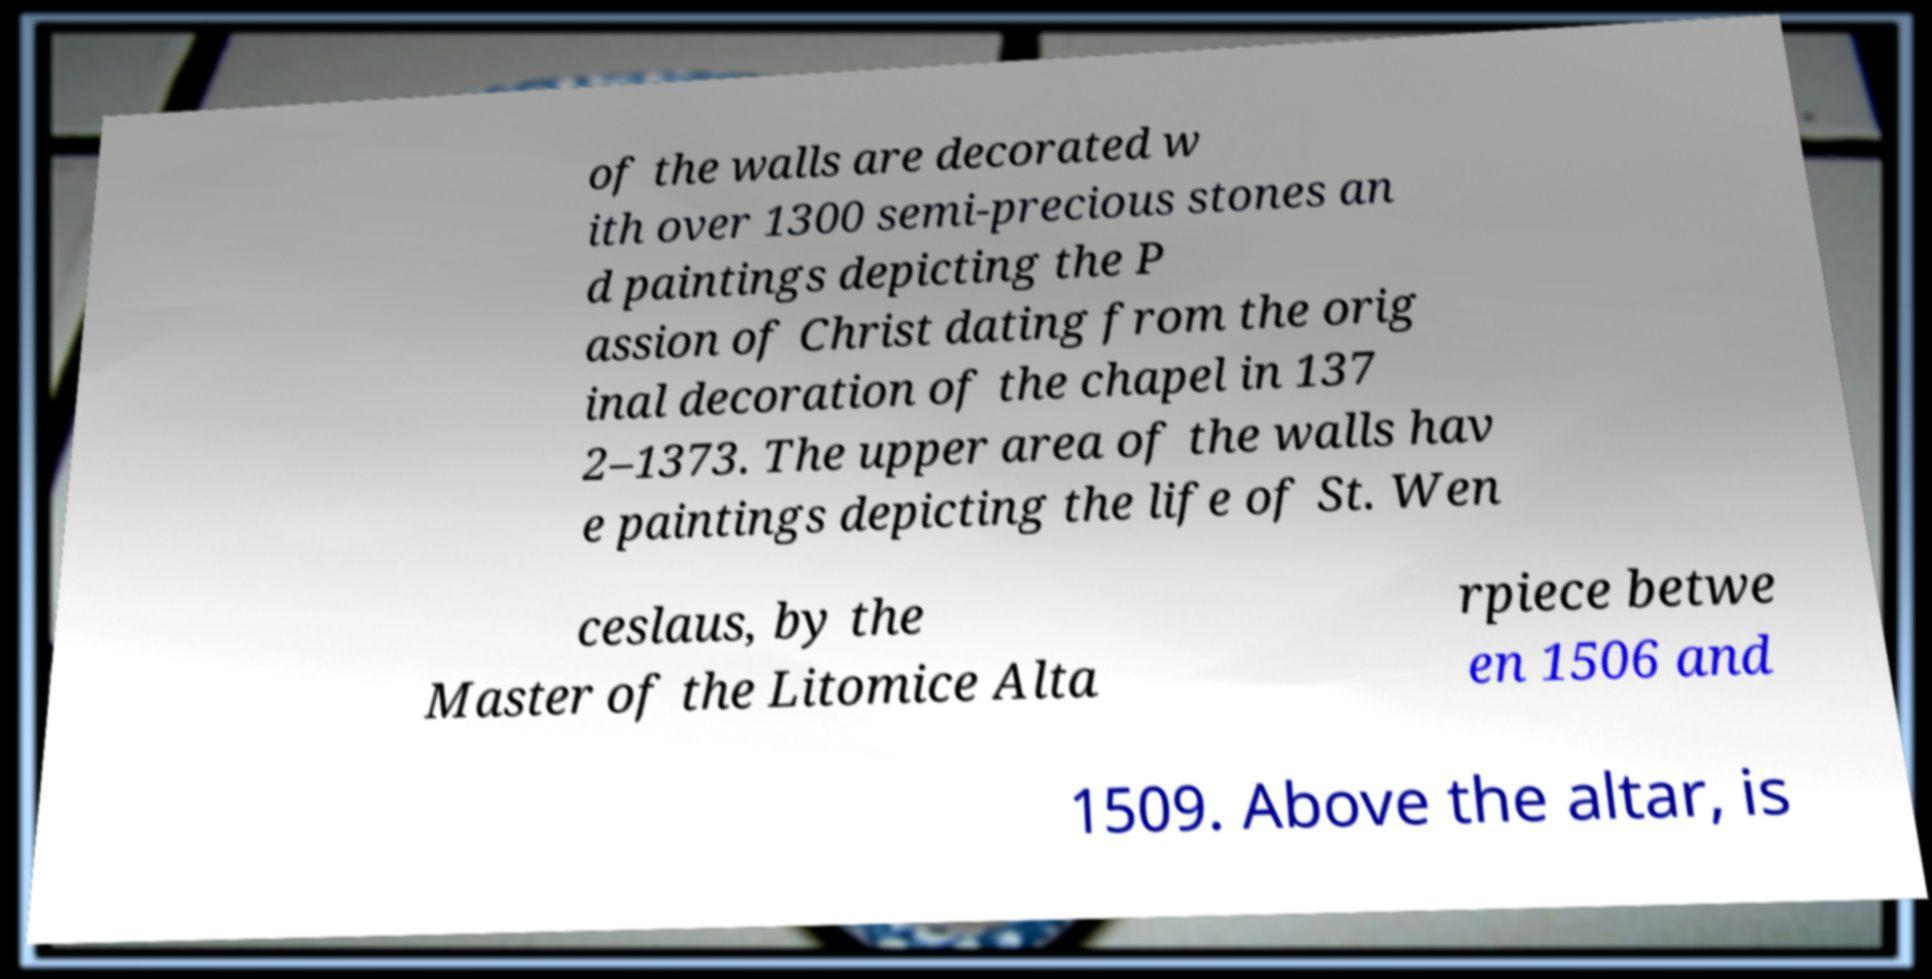There's text embedded in this image that I need extracted. Can you transcribe it verbatim? of the walls are decorated w ith over 1300 semi-precious stones an d paintings depicting the P assion of Christ dating from the orig inal decoration of the chapel in 137 2–1373. The upper area of the walls hav e paintings depicting the life of St. Wen ceslaus, by the Master of the Litomice Alta rpiece betwe en 1506 and 1509. Above the altar, is 